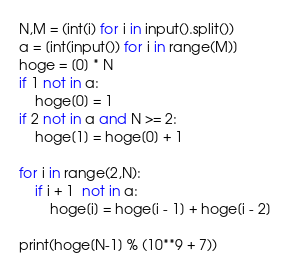<code> <loc_0><loc_0><loc_500><loc_500><_Python_>N,M = (int(i) for i in input().split())
a = [int(input()) for i in range(M)]
hoge = [0] * N
if 1 not in a:
    hoge[0] = 1
if 2 not in a and N >= 2:
    hoge[1] = hoge[0] + 1

for i in range(2,N):
    if i + 1  not in a:
        hoge[i] = hoge[i - 1] + hoge[i - 2]

print(hoge[N-1] % (10**9 + 7))</code> 